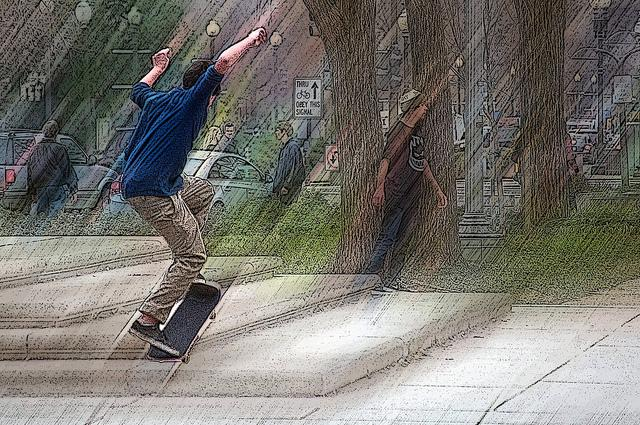World Skate is highest governing body of which game?

Choices:
A) swimming
B) kiting
C) skateboarding
D) surfing skateboarding 